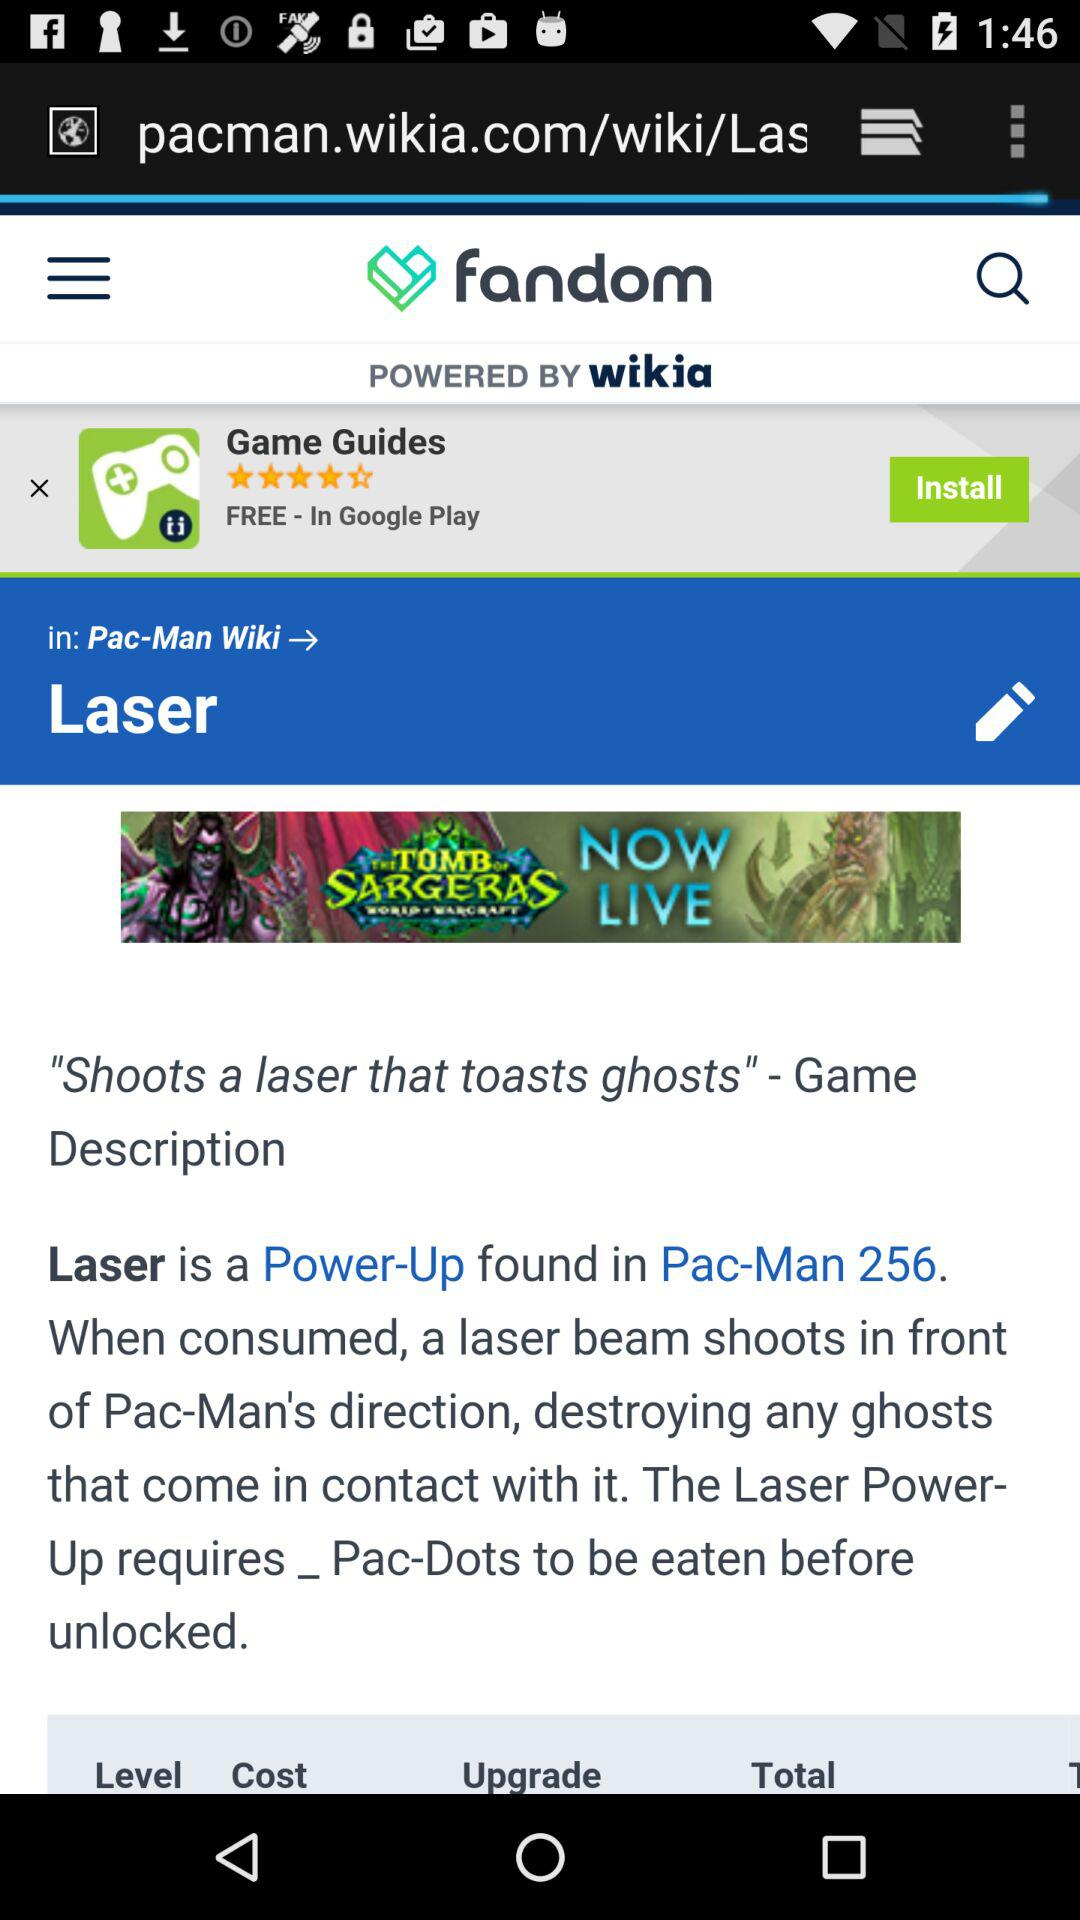What's the application name? The name of the application is "fandom". 